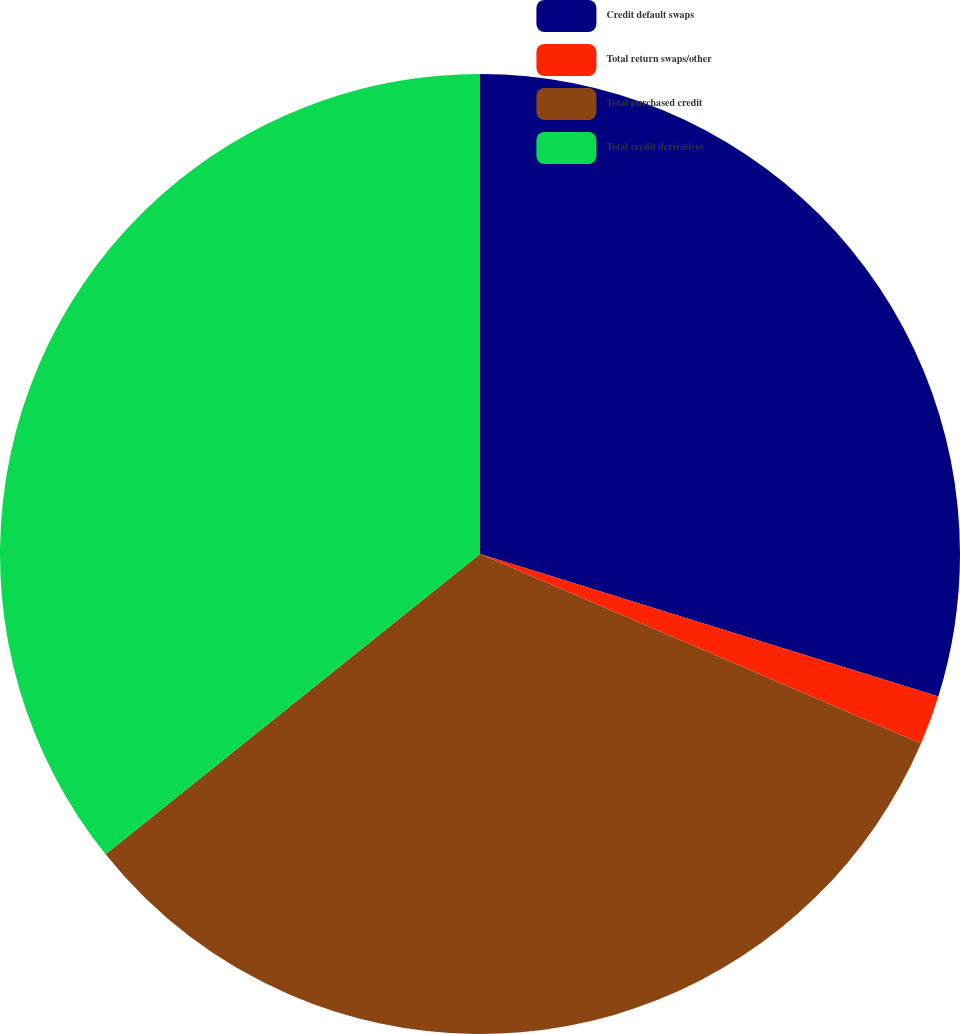Convert chart to OTSL. <chart><loc_0><loc_0><loc_500><loc_500><pie_chart><fcel>Credit default swaps<fcel>Total return swaps/other<fcel>Total purchased credit<fcel>Total credit derivatives<nl><fcel>29.8%<fcel>1.66%<fcel>32.78%<fcel>35.76%<nl></chart> 